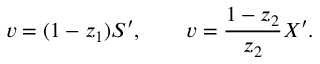Convert formula to latex. <formula><loc_0><loc_0><loc_500><loc_500>v = ( 1 - z _ { 1 } ) S ^ { \prime } , \quad v = { \frac { 1 - z _ { 2 } } { z _ { 2 } } } X ^ { \prime } .</formula> 